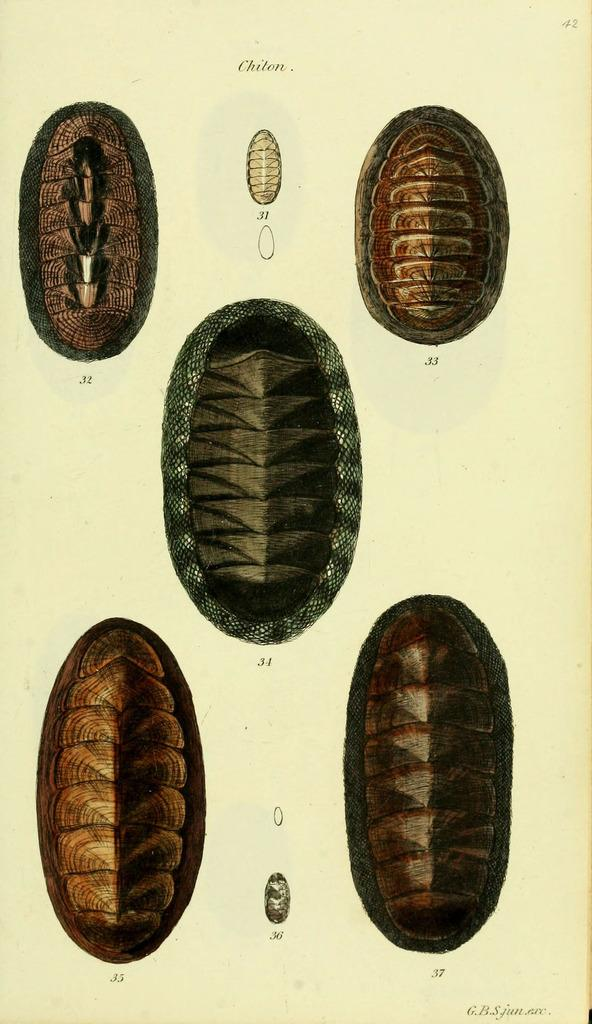What type of objects are present in the image? There are shells of cockroaches in the image. What color is the stocking that the cockroaches are wearing in the image? There are no cockroaches or stockings present in the image; it only contains shells of cockroaches. 